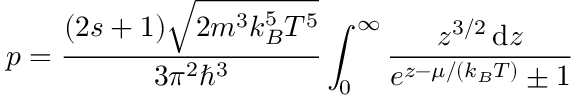<formula> <loc_0><loc_0><loc_500><loc_500>p = { \frac { ( 2 s + 1 ) { \sqrt { 2 m ^ { 3 } k _ { B } ^ { 5 } T ^ { 5 } } } } { 3 \pi ^ { 2 } \hbar { ^ } { 3 } } } \int _ { 0 } ^ { \infty } { \frac { z ^ { 3 / 2 } \, d z } { e ^ { z - \mu / ( k _ { B } T ) } \pm 1 } }</formula> 